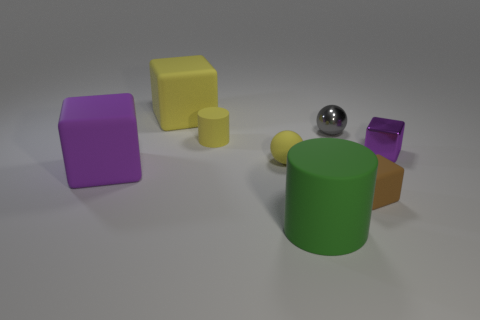Subtract 1 blocks. How many blocks are left? 3 Add 2 tiny yellow cylinders. How many objects exist? 10 Subtract all cylinders. How many objects are left? 6 Subtract all large cyan matte cubes. Subtract all yellow rubber objects. How many objects are left? 5 Add 6 brown cubes. How many brown cubes are left? 7 Add 2 brown metallic spheres. How many brown metallic spheres exist? 2 Subtract 1 green cylinders. How many objects are left? 7 